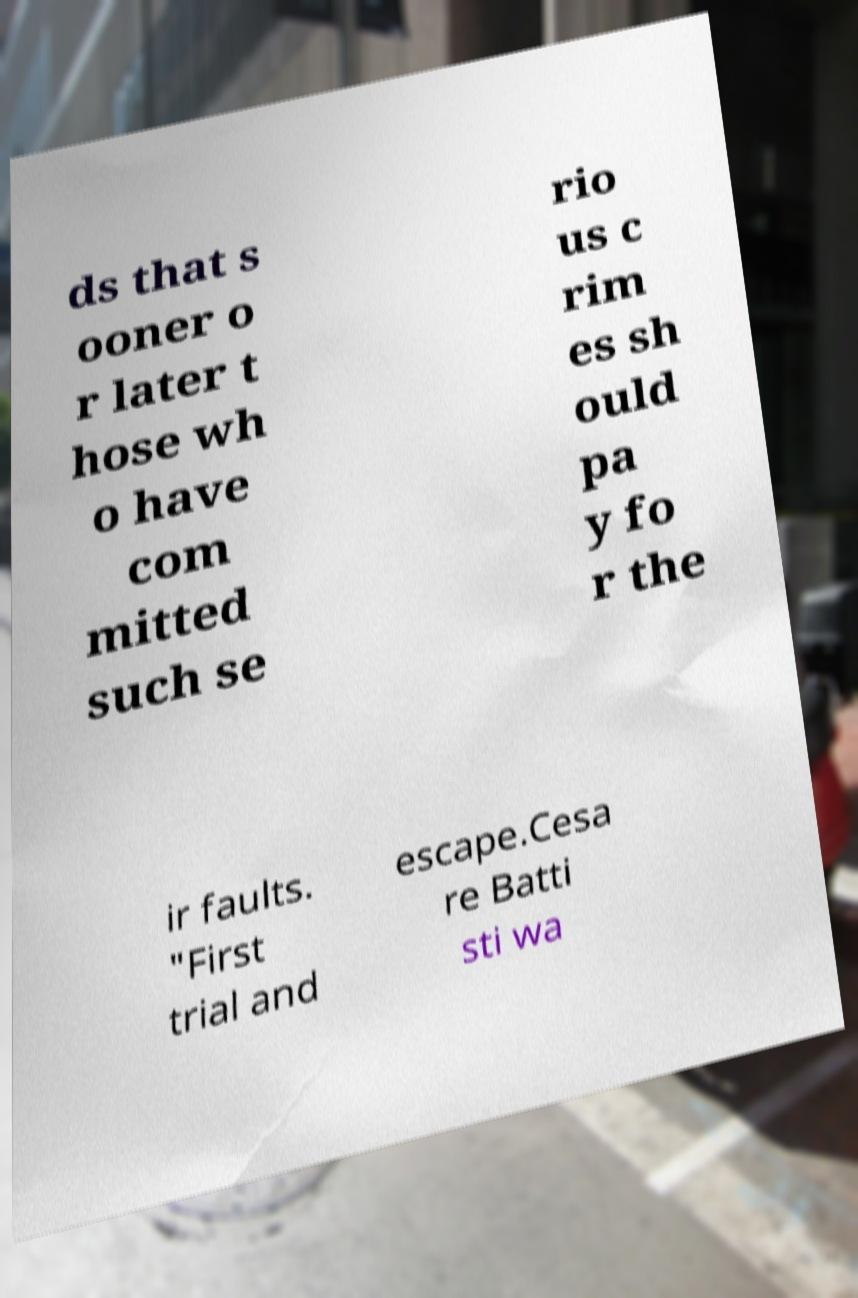Can you read and provide the text displayed in the image?This photo seems to have some interesting text. Can you extract and type it out for me? ds that s ooner o r later t hose wh o have com mitted such se rio us c rim es sh ould pa y fo r the ir faults. "First trial and escape.Cesa re Batti sti wa 